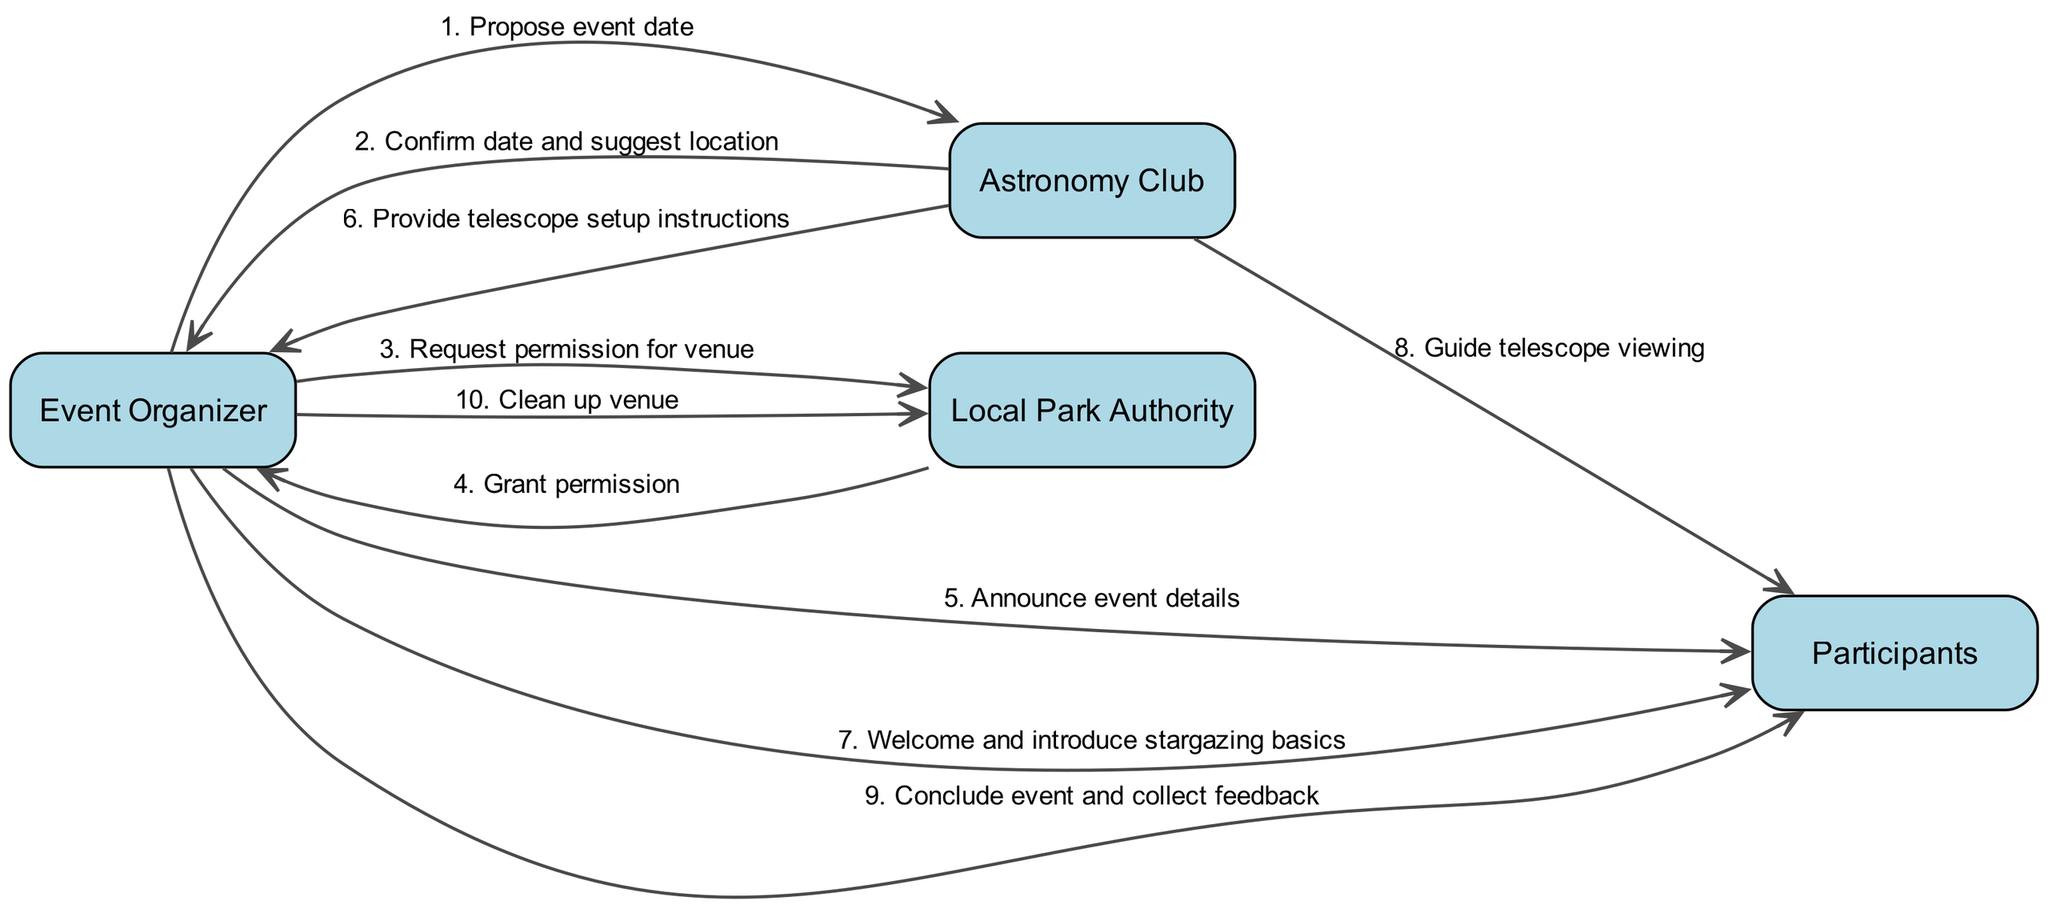What is the first action taken by the Event Organizer? The Event Organizer's first action in the sequence diagram is to propose an event date to the Astronomy Club. This is the first connection depicted in the flow of actions.
Answer: Propose event date How many actors are involved in the event? The diagram lists four distinct actors involved in the event: Event Organizer, Astronomy Club, Local Park Authority, and Participants. This can be counted directly from the actors section.
Answer: Four Which actor is responsible for guiding telescope viewing? The Astronomy Club is the actor responsible for guiding the telescope viewing, as indicated in the sequence where they interact with Participants.
Answer: Astronomy Club What action occurs just before the cleanup of the venue? Just before the cleanup of the venue, the Event Organizer concludes the event and collects feedback from the Participants. This can be identified by tracking the sequence right before the cleanup action.
Answer: Conclude event and collect feedback Which actor grants permission for the venue? The Local Park Authority is the actor that grants permission for the venue, as shown in the sequence following the Event Organizer's request.
Answer: Local Park Authority What action does the Astronomy Club take after confirming the event date? After confirming the date, the Astronomy Club suggests a location for the event. This follows from the confirmation process initiated by the Event Organizer.
Answer: Suggest location How many actions are initiated by the Event Organizer? There are four actions initiated by the Event Organizer throughout the diagram: proposing the event date, requesting permission, announcing event details, and concluding the event. Counting each interaction shows the total.
Answer: Four What is the last action depicted in the sequence? The last action depicted in the sequence is the Event Organizer cleaning up the venue. This shows the final responsibility taken in the event process.
Answer: Clean up venue What is the relationship between the Astronomy Club and Participants after the Event Organizer's introduction? The relationship established is that the Astronomy Club guides telescope viewing for the Participants, indicating a direct interaction focused on shared activities during the event.
Answer: Guide telescope viewing 